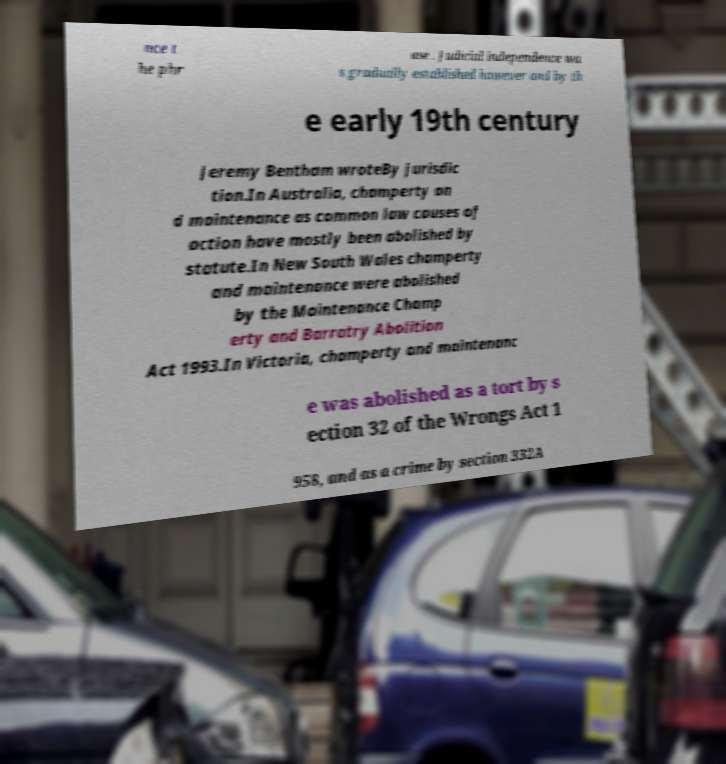Can you accurately transcribe the text from the provided image for me? nce t he phr ase . Judicial independence wa s gradually established however and by th e early 19th century Jeremy Bentham wroteBy jurisdic tion.In Australia, champerty an d maintenance as common law causes of action have mostly been abolished by statute.In New South Wales champerty and maintenance were abolished by the Maintenance Champ erty and Barratry Abolition Act 1993.In Victoria, champerty and maintenanc e was abolished as a tort by s ection 32 of the Wrongs Act 1 958, and as a crime by section 332A 